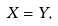Convert formula to latex. <formula><loc_0><loc_0><loc_500><loc_500>X = Y ,</formula> 